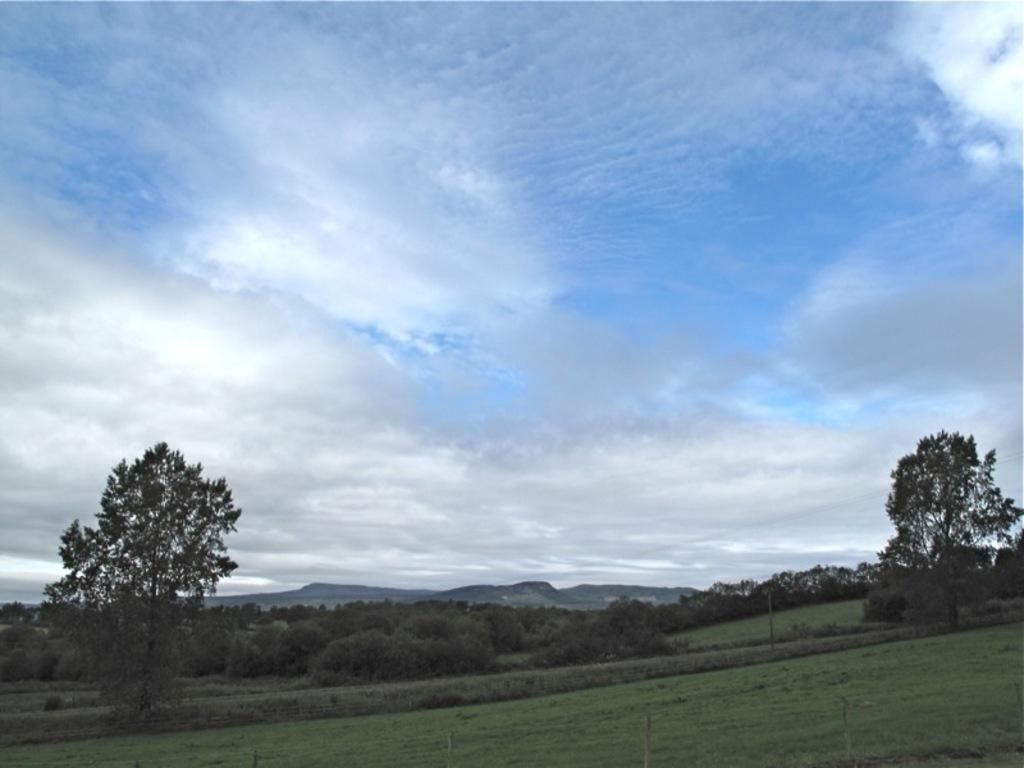What type of landscape is depicted in the image? There is a meadow in the image. What can be seen in the distance behind the meadow? There are trees in the background of the image. What else is visible in the background of the image? The sky is visible in the background of the image. What is the condition of the sky in the image? Clouds are present in the sky. Where is the queen standing in the image? There is no queen present in the image; it features a meadow, trees, and a sky with clouds. What type of patch can be seen on the harbor in the image? There is no harbor present in the image; it features a meadow, trees, and a sky with clouds. 